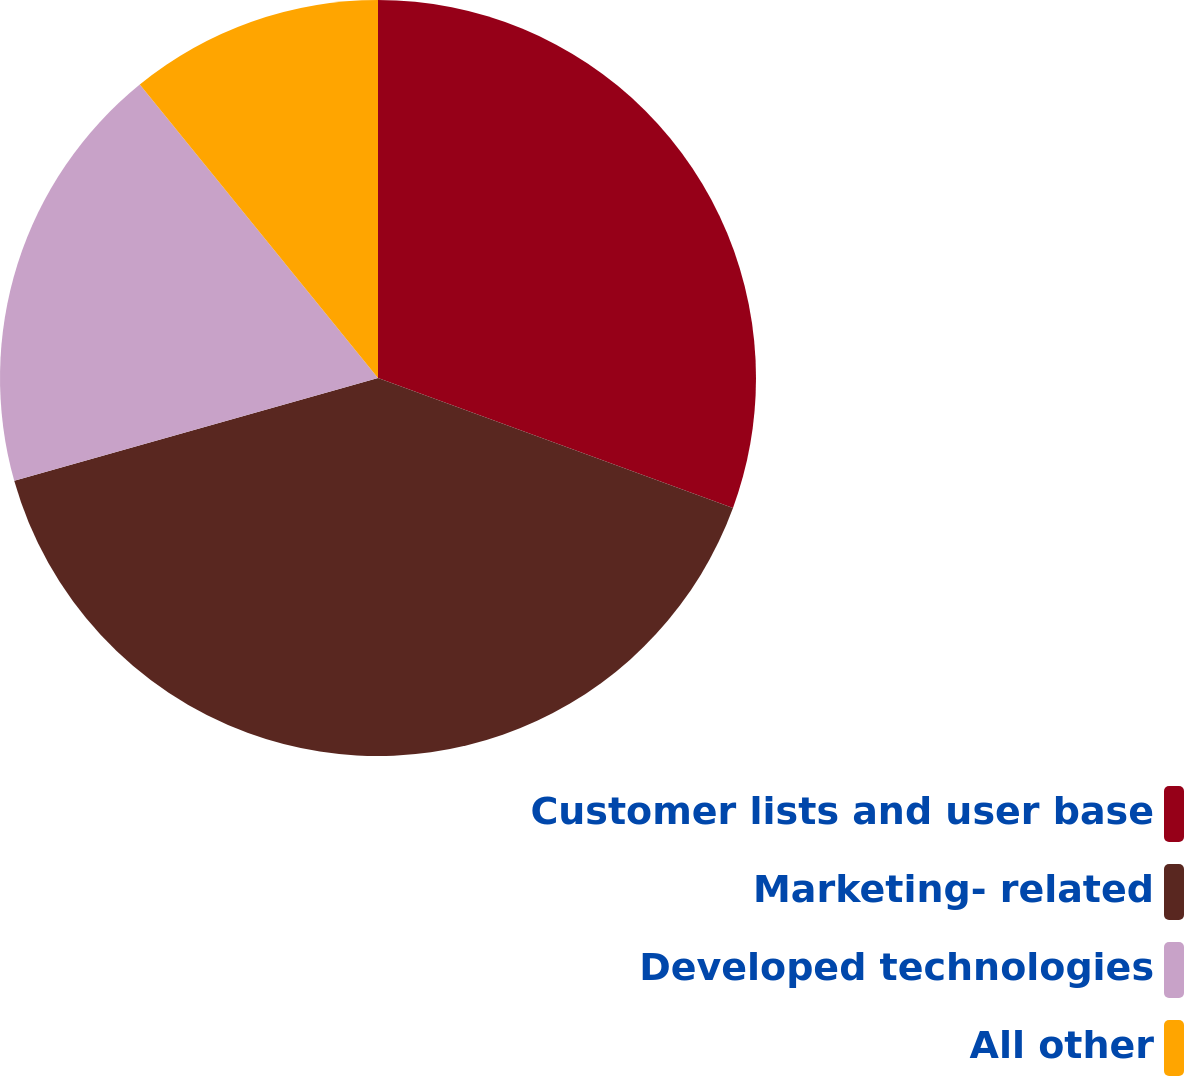Convert chart to OTSL. <chart><loc_0><loc_0><loc_500><loc_500><pie_chart><fcel>Customer lists and user base<fcel>Marketing- related<fcel>Developed technologies<fcel>All other<nl><fcel>30.58%<fcel>40.03%<fcel>18.53%<fcel>10.85%<nl></chart> 